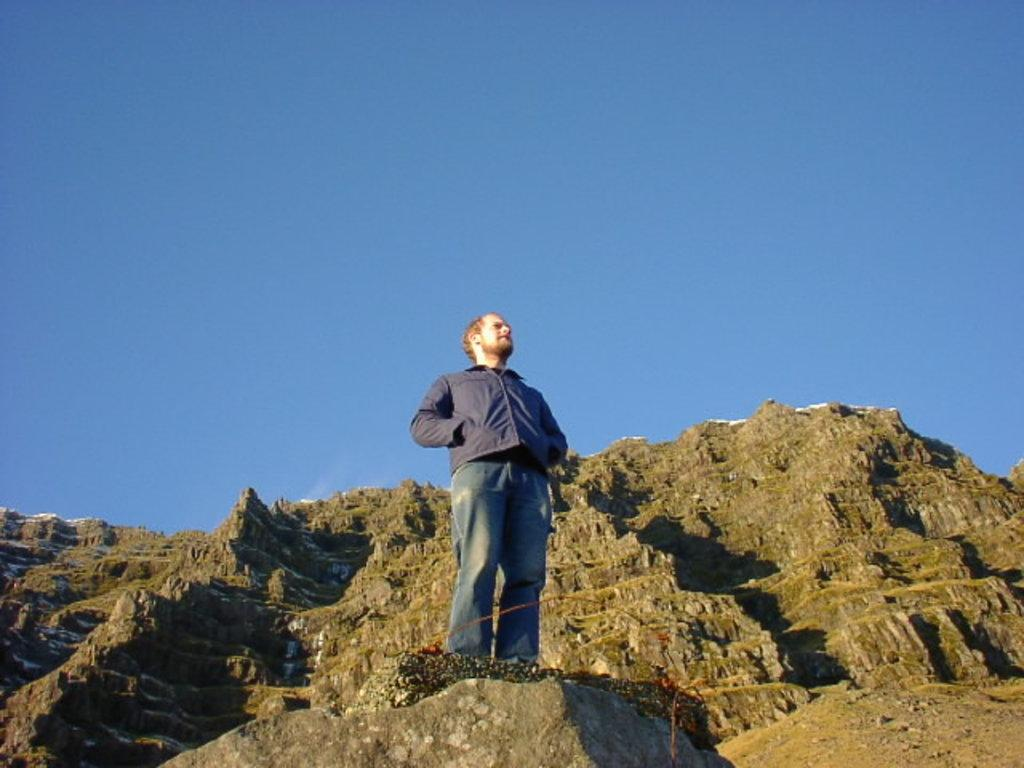What is the main subject of the image? There is a man standing in the center of the image. What can be seen in the background of the image? Hills and an object are visible in the background of the image. What is visible at the top of the image? The sky is visible at the top of the image. What is the income of the farmer in the image? There is no farmer present in the image, and therefore no information about their income can be provided. What type of stone is visible in the image? There is no stone visible in the image. 